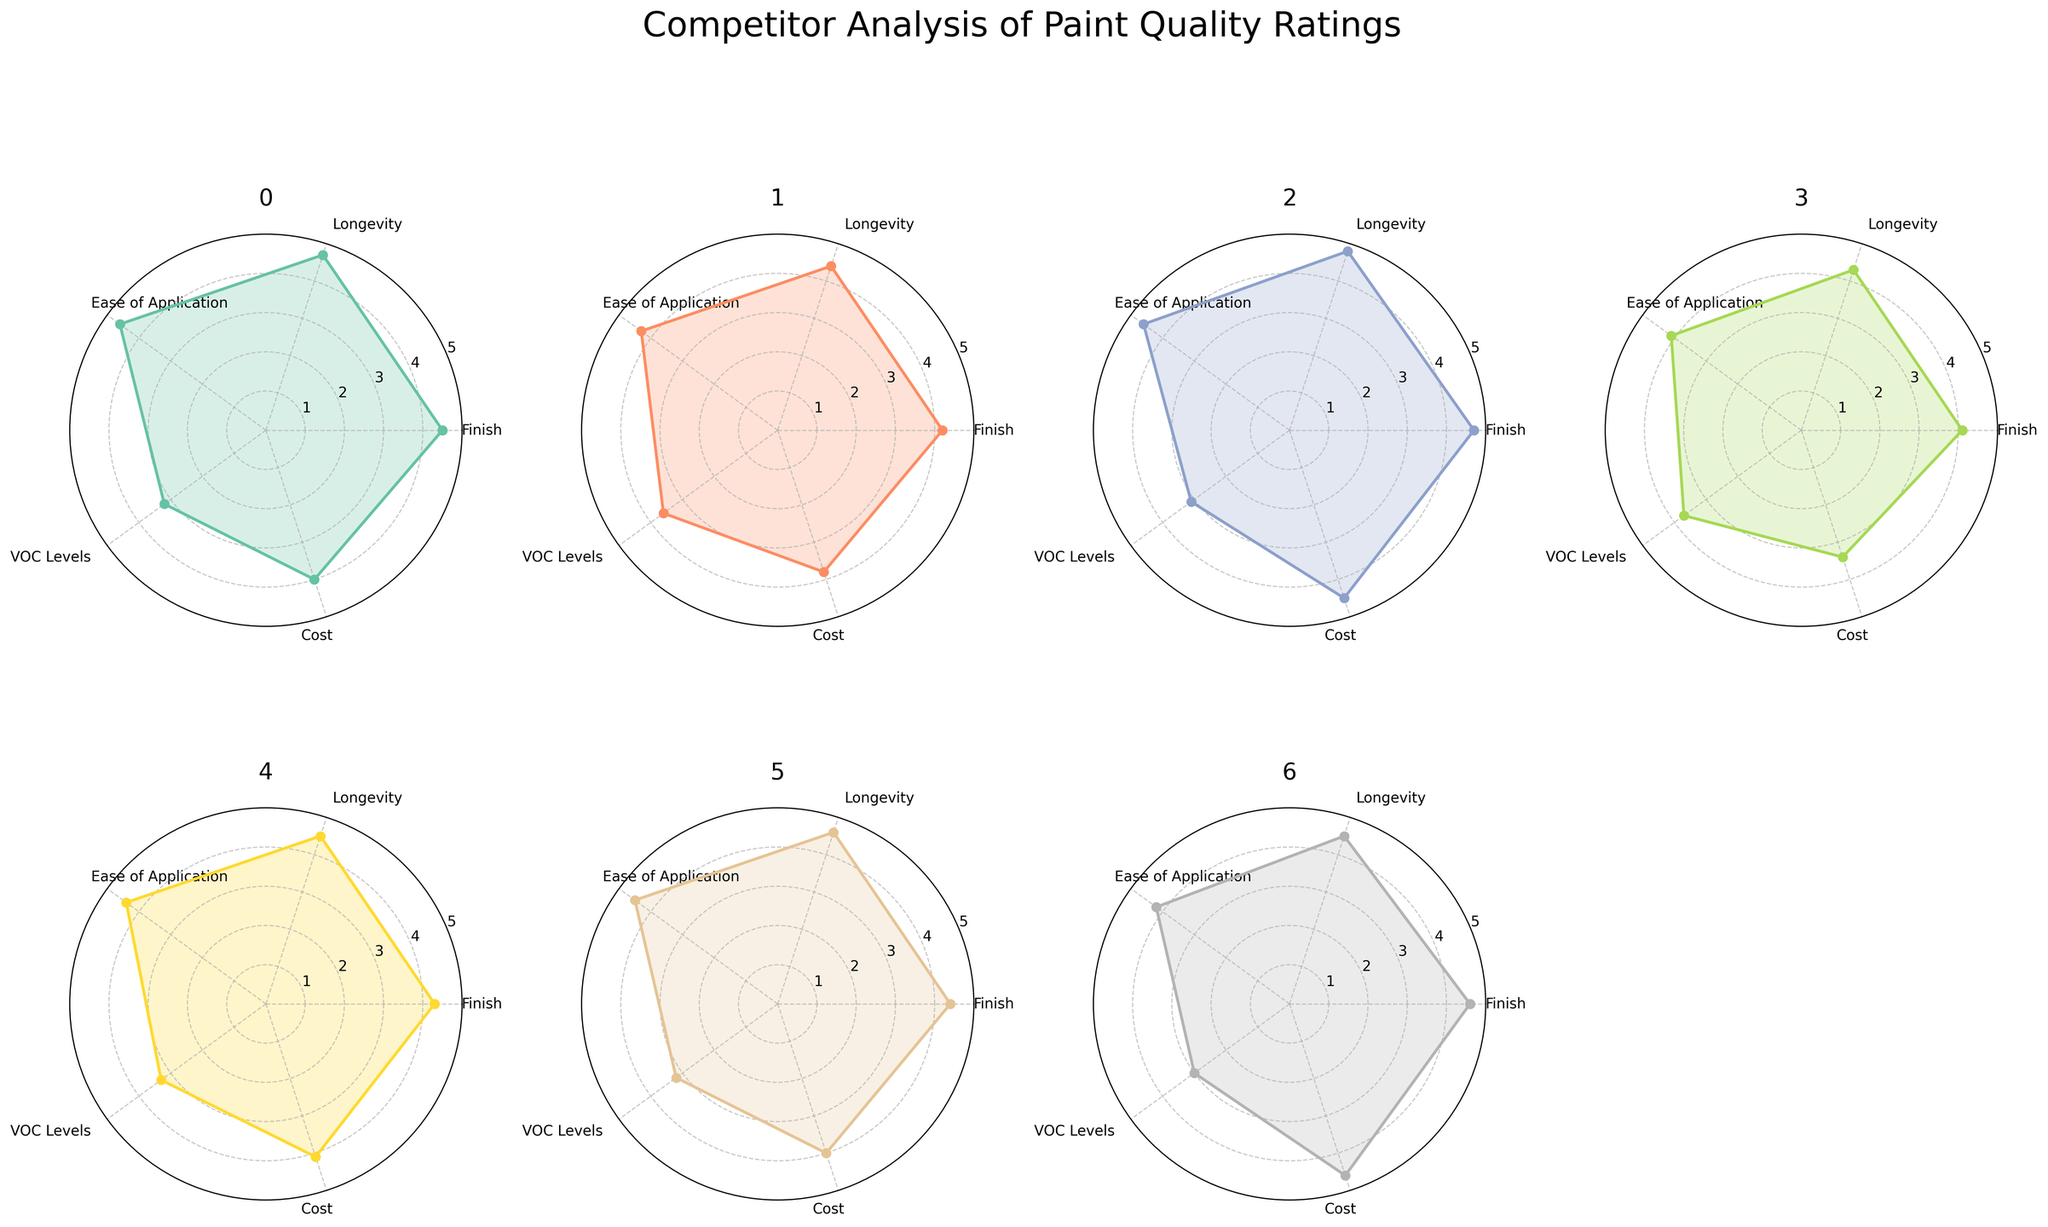Which manufacturer has the highest rating for Longevity? Check the Longevity section for the highest rating in each subplot. Benjamin Moore has the highest rating (4.8) in this category.
Answer: Benjamin Moore What is the range of VOC Levels ratings across all manufacturers? The lowest VOC Levels rating is 3.0 (Farrow & Ball), and the highest is 3.7 (Valspar). Subtract the lowest from the highest to find the range: 3.7 - 3.0 = 0.7.
Answer: 0.7 Which manufacturer has the lowest rating in Cost? Compare the Cost ratings in each subplot. Valspar has the lowest (3.4).
Answer: Valspar How does the Finish rating of Sherwin-Williams compare to that of Valspar? Look at the Finish ratings in the subplots for Sherwin-Williams (4.5) and Valspar (4.1). Subtract Valspar's rating from Sherwin-Williams' to find the difference: 4.5 - 4.1 = 0.4.
Answer: Sherwin-Williams is 0.4 higher On average, how do the Ease of Application ratings compare to the Cost ratings for all manufacturers? For each manufacturer, average the ratings of Ease of Application and Cost:
  (4.6 + 4.0 + 4.3 + 3.8 + 4.6 + 4.5 + 4.1 + 3.4 + 4.4 + 4.1 + 4.5 + 4.0 + 4.2 + 4.6)/14 = 4.21 (Ease of Application) and (3.7 + 4.0 + 3.2 + 4.5 + 3.0 + 4.1 + 4.5 + 4.0 + 4.2 + 3.8 + 3.4)/8 = 3.97 (Cost).
Answer: Ease of Application is higher Across all categories, which manufacturer has the most consistently high ratings? Evaluate the range and consistency of ratings in each subplot. Benjamin Moore has consistently high ratings (4.5-4.8).
Answer: Benjamin Moore What is the highest VOC Levels rating among all manufacturers? Find the VOC Levels rating in each subplot and identify the highest. Valspar has the highest VOC Levels rating of 3.7.
Answer: 3.7 Which manufacturer has the smallest variance in ratings across the five categories? Calculate the variance for each manufacturer's ratings: 
  For example, Farrow & Ball: 
  - Mean: (4.6 + 4.5 + 4.2 + 3.0 + 4.6)/5 = 4.18 
  - Variance: ( (4.6 - 4.18)^2 + (4.5 - 4.18)^2 + (4.2 - 4.18)^2 + (3.0 - 4.18)^2 + (4.6 - 4.18)^2 ) / 5 
  - Simplify variance calculation for each manufacturer; Farrow & Ball has a small variance.
Answer: Farrow & Ball 